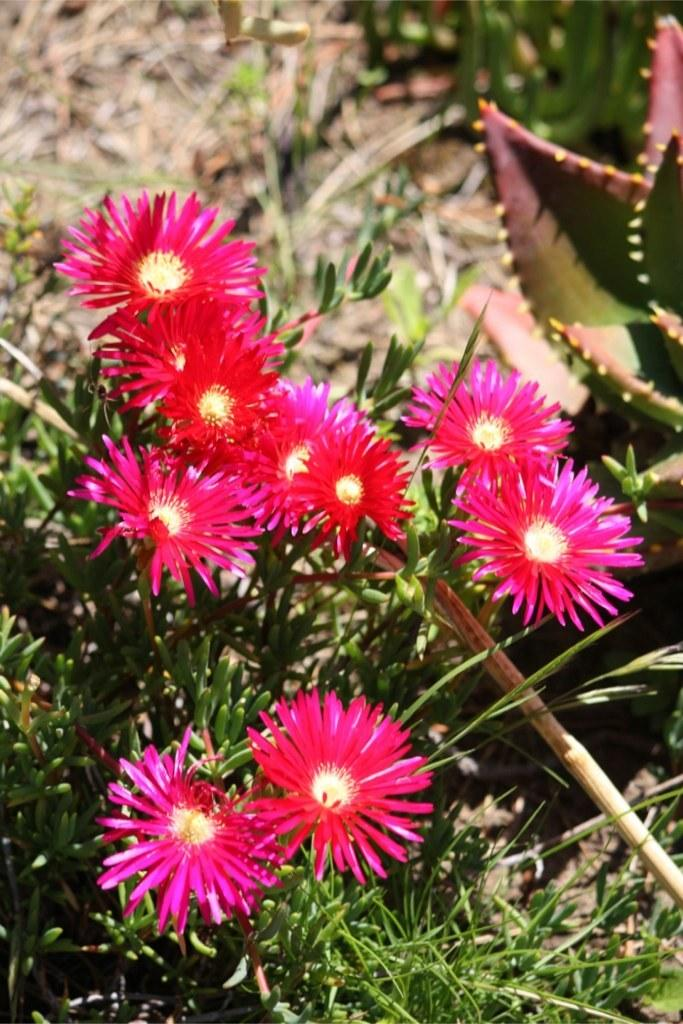What type of plant is visible in the image? The image shows a plant with a bunch of flowers on it. What else can be seen in the image besides the plant? There is a stick visible in the image. How much money is being exchanged between the flowers in the image? There is no money exchange happening between the flowers in the image, as they are part of a plant and do not engage in financial transactions. 